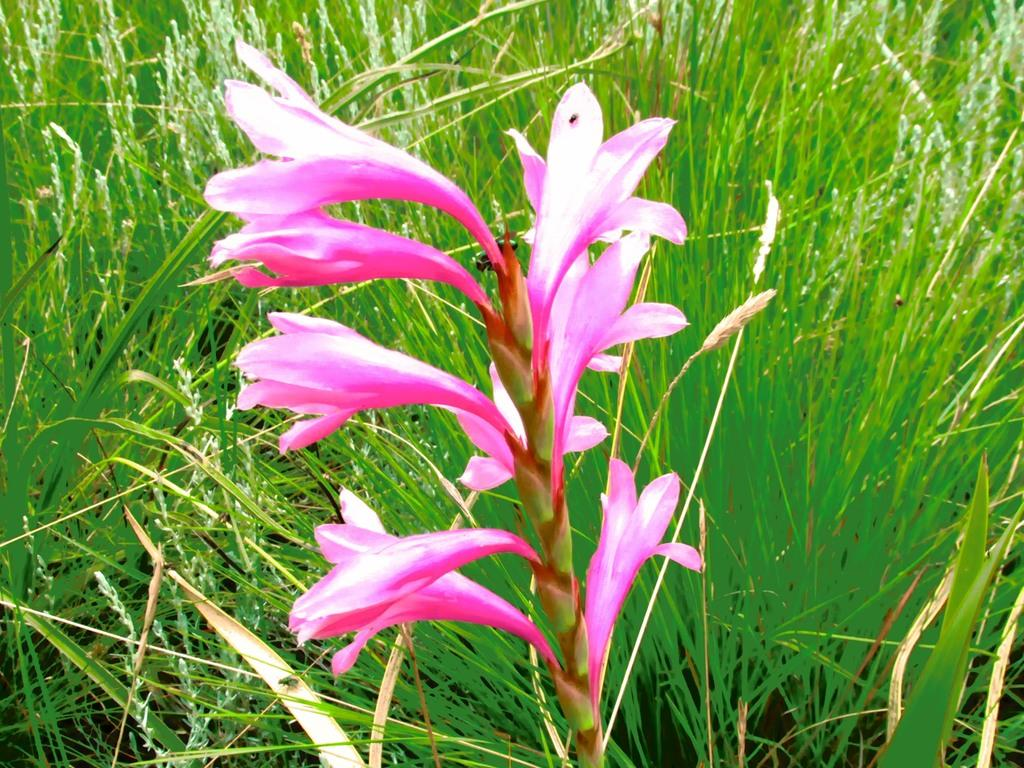Where was the image taken? The image was taken outdoors. What can be seen in the background of the image? There is a ground with grass in the background. What is the main subject of the image? There is a plant in the middle of the image. What is special about the plant? The plant has beautiful pink flowers. How does the plant feel about its stomach in the image? Plants do not have stomachs, so this question is not applicable to the image. 